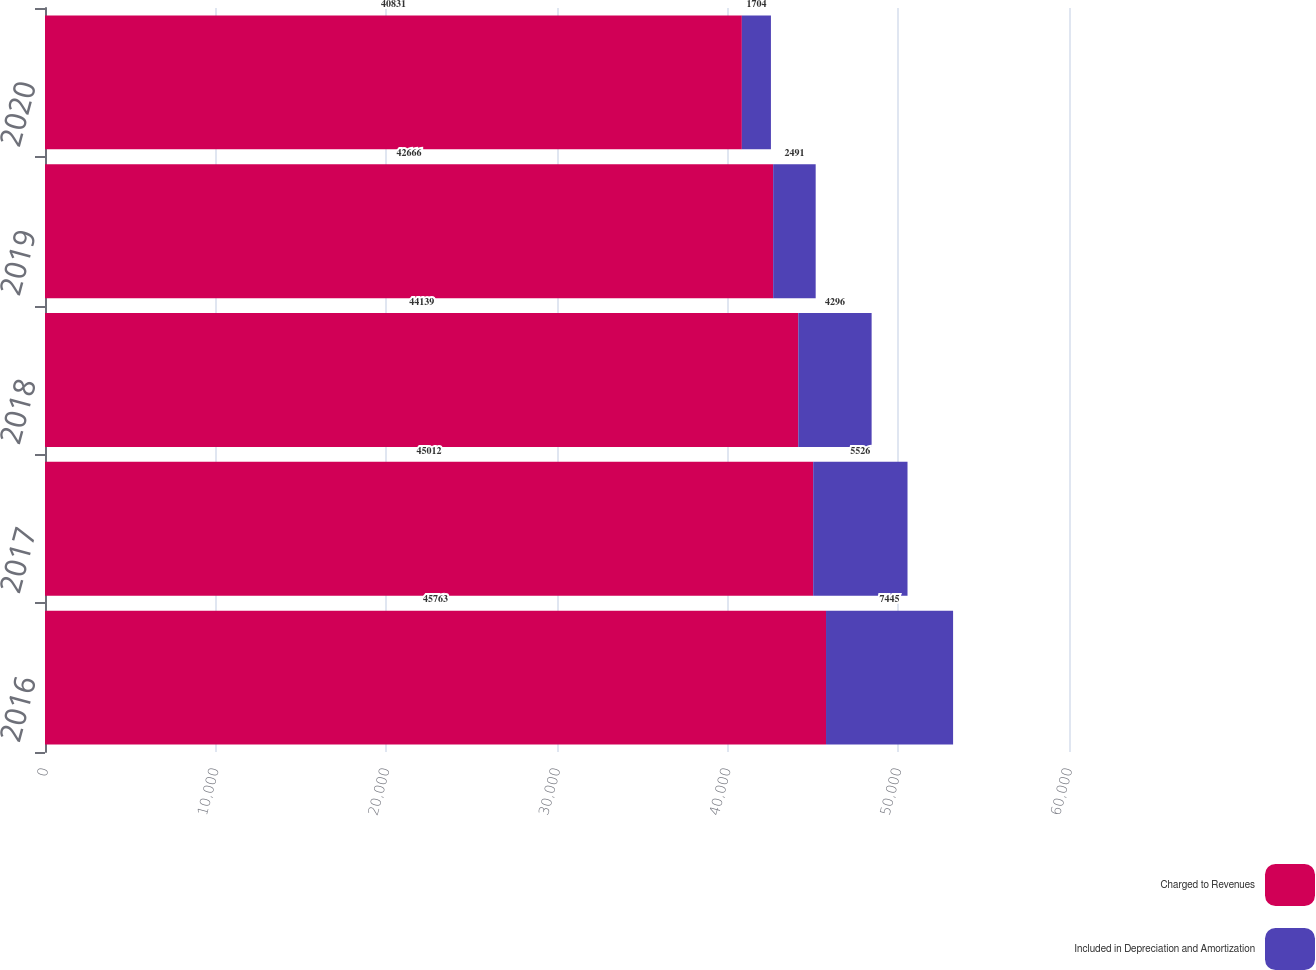<chart> <loc_0><loc_0><loc_500><loc_500><stacked_bar_chart><ecel><fcel>2016<fcel>2017<fcel>2018<fcel>2019<fcel>2020<nl><fcel>Charged to Revenues<fcel>45763<fcel>45012<fcel>44139<fcel>42666<fcel>40831<nl><fcel>Included in Depreciation and Amortization<fcel>7445<fcel>5526<fcel>4296<fcel>2491<fcel>1704<nl></chart> 